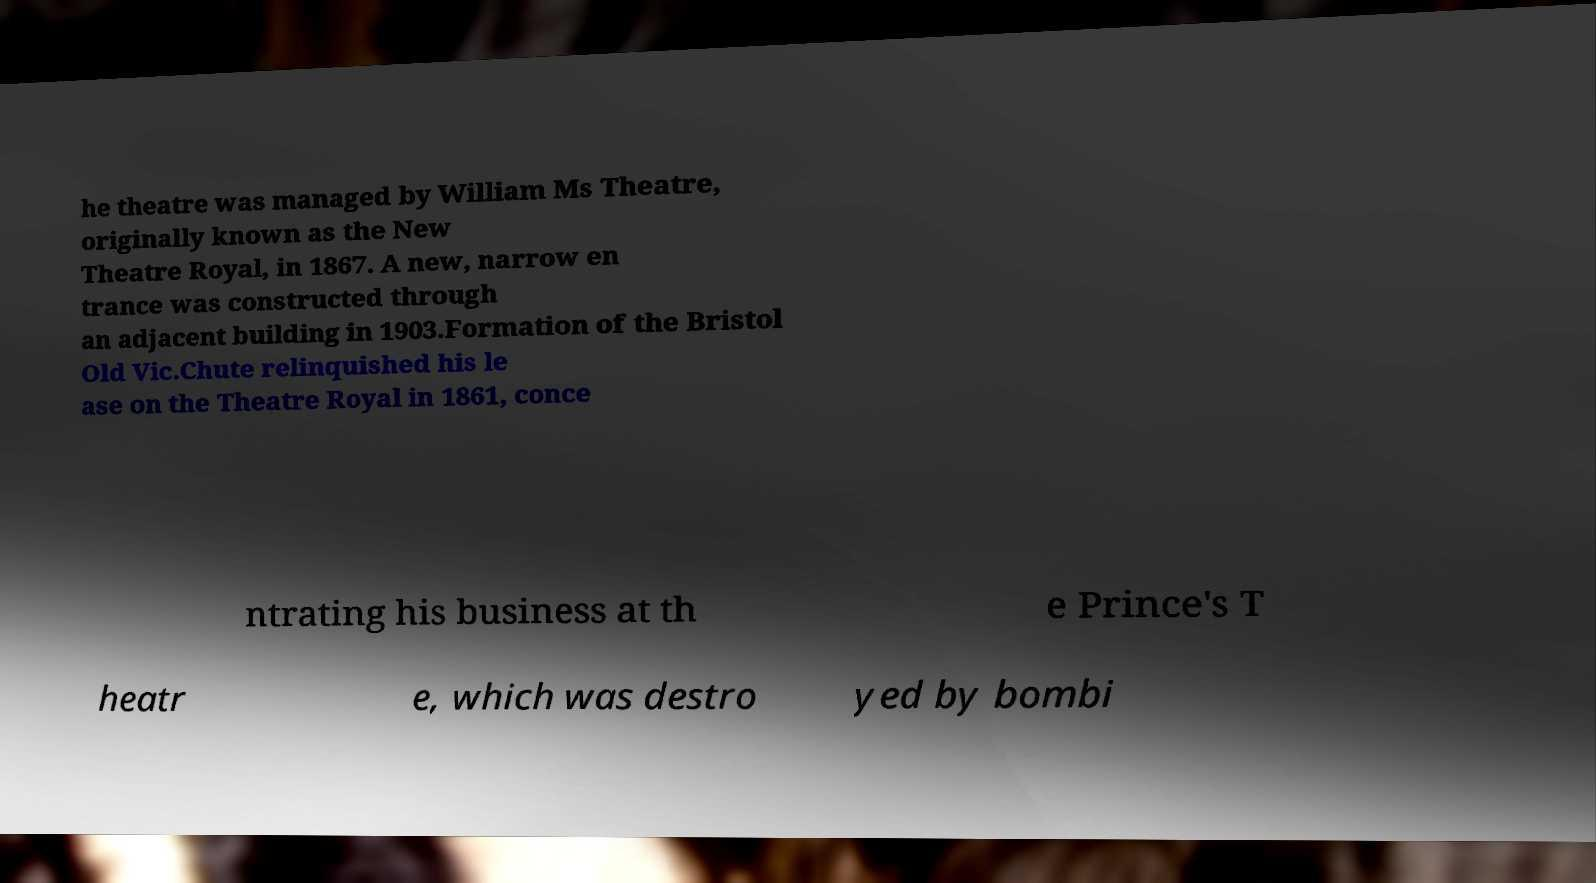Can you accurately transcribe the text from the provided image for me? he theatre was managed by William Ms Theatre, originally known as the New Theatre Royal, in 1867. A new, narrow en trance was constructed through an adjacent building in 1903.Formation of the Bristol Old Vic.Chute relinquished his le ase on the Theatre Royal in 1861, conce ntrating his business at th e Prince's T heatr e, which was destro yed by bombi 